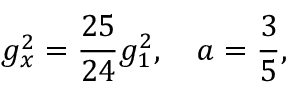<formula> <loc_0><loc_0><loc_500><loc_500>g _ { x } ^ { 2 } = { \frac { 2 5 } { 2 4 } } g _ { 1 } ^ { 2 } , a = { \frac { 3 } { 5 } } ,</formula> 